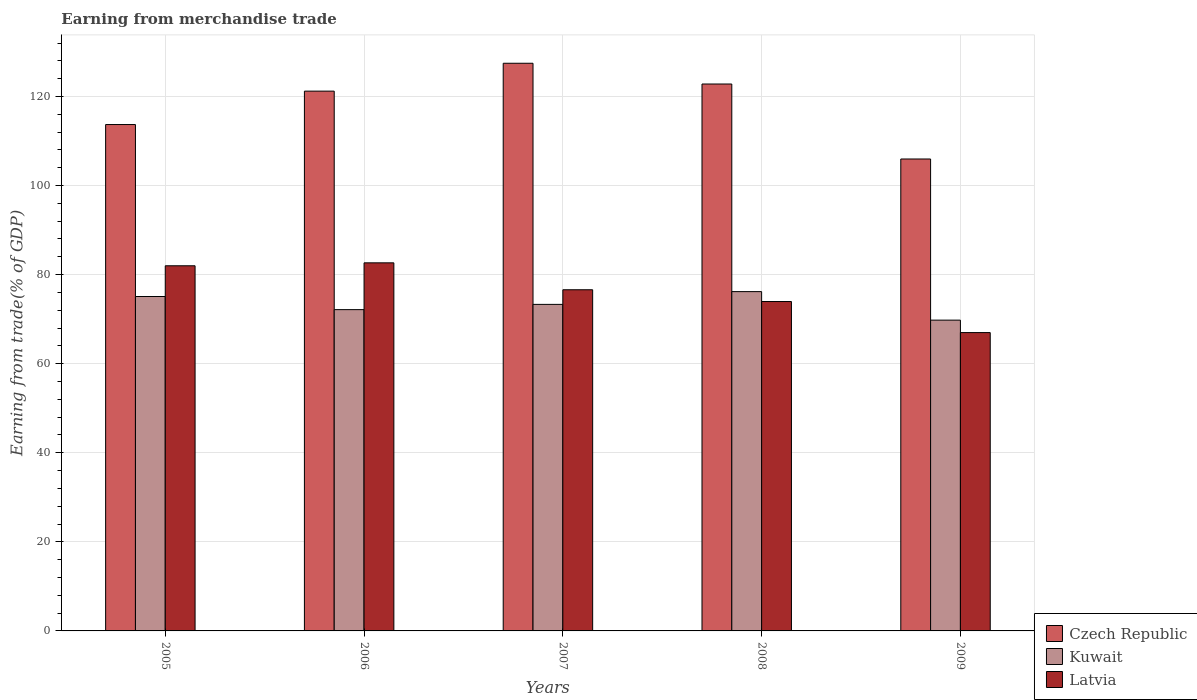How many different coloured bars are there?
Keep it short and to the point. 3. How many bars are there on the 3rd tick from the right?
Keep it short and to the point. 3. What is the earnings from trade in Kuwait in 2008?
Provide a short and direct response. 76.19. Across all years, what is the maximum earnings from trade in Kuwait?
Your answer should be very brief. 76.19. Across all years, what is the minimum earnings from trade in Czech Republic?
Ensure brevity in your answer.  105.97. In which year was the earnings from trade in Kuwait maximum?
Your response must be concise. 2008. What is the total earnings from trade in Latvia in the graph?
Provide a short and direct response. 382.18. What is the difference between the earnings from trade in Kuwait in 2005 and that in 2007?
Your answer should be compact. 1.77. What is the difference between the earnings from trade in Latvia in 2005 and the earnings from trade in Czech Republic in 2006?
Provide a short and direct response. -39.21. What is the average earnings from trade in Kuwait per year?
Offer a very short reply. 73.3. In the year 2006, what is the difference between the earnings from trade in Czech Republic and earnings from trade in Kuwait?
Make the answer very short. 49.06. What is the ratio of the earnings from trade in Czech Republic in 2006 to that in 2007?
Offer a terse response. 0.95. What is the difference between the highest and the second highest earnings from trade in Latvia?
Offer a terse response. 0.66. What is the difference between the highest and the lowest earnings from trade in Kuwait?
Offer a terse response. 6.4. In how many years, is the earnings from trade in Czech Republic greater than the average earnings from trade in Czech Republic taken over all years?
Provide a short and direct response. 3. Is the sum of the earnings from trade in Czech Republic in 2007 and 2008 greater than the maximum earnings from trade in Latvia across all years?
Make the answer very short. Yes. What does the 2nd bar from the left in 2007 represents?
Provide a succinct answer. Kuwait. What does the 1st bar from the right in 2008 represents?
Your response must be concise. Latvia. Is it the case that in every year, the sum of the earnings from trade in Czech Republic and earnings from trade in Latvia is greater than the earnings from trade in Kuwait?
Keep it short and to the point. Yes. How many years are there in the graph?
Make the answer very short. 5. Are the values on the major ticks of Y-axis written in scientific E-notation?
Offer a terse response. No. Does the graph contain any zero values?
Offer a very short reply. No. How many legend labels are there?
Make the answer very short. 3. How are the legend labels stacked?
Give a very brief answer. Vertical. What is the title of the graph?
Give a very brief answer. Earning from merchandise trade. Does "Vietnam" appear as one of the legend labels in the graph?
Provide a succinct answer. No. What is the label or title of the Y-axis?
Ensure brevity in your answer.  Earning from trade(% of GDP). What is the Earning from trade(% of GDP) in Czech Republic in 2005?
Your answer should be compact. 113.7. What is the Earning from trade(% of GDP) in Kuwait in 2005?
Provide a succinct answer. 75.09. What is the Earning from trade(% of GDP) of Latvia in 2005?
Offer a terse response. 81.99. What is the Earning from trade(% of GDP) in Czech Republic in 2006?
Make the answer very short. 121.2. What is the Earning from trade(% of GDP) of Kuwait in 2006?
Give a very brief answer. 72.14. What is the Earning from trade(% of GDP) of Latvia in 2006?
Offer a terse response. 82.65. What is the Earning from trade(% of GDP) in Czech Republic in 2007?
Keep it short and to the point. 127.46. What is the Earning from trade(% of GDP) in Kuwait in 2007?
Your answer should be compact. 73.32. What is the Earning from trade(% of GDP) of Latvia in 2007?
Offer a very short reply. 76.6. What is the Earning from trade(% of GDP) of Czech Republic in 2008?
Ensure brevity in your answer.  122.8. What is the Earning from trade(% of GDP) of Kuwait in 2008?
Provide a short and direct response. 76.19. What is the Earning from trade(% of GDP) in Latvia in 2008?
Ensure brevity in your answer.  73.96. What is the Earning from trade(% of GDP) of Czech Republic in 2009?
Offer a very short reply. 105.97. What is the Earning from trade(% of GDP) in Kuwait in 2009?
Provide a short and direct response. 69.78. What is the Earning from trade(% of GDP) of Latvia in 2009?
Provide a succinct answer. 66.99. Across all years, what is the maximum Earning from trade(% of GDP) in Czech Republic?
Make the answer very short. 127.46. Across all years, what is the maximum Earning from trade(% of GDP) of Kuwait?
Provide a short and direct response. 76.19. Across all years, what is the maximum Earning from trade(% of GDP) in Latvia?
Provide a succinct answer. 82.65. Across all years, what is the minimum Earning from trade(% of GDP) in Czech Republic?
Give a very brief answer. 105.97. Across all years, what is the minimum Earning from trade(% of GDP) in Kuwait?
Make the answer very short. 69.78. Across all years, what is the minimum Earning from trade(% of GDP) in Latvia?
Keep it short and to the point. 66.99. What is the total Earning from trade(% of GDP) in Czech Republic in the graph?
Keep it short and to the point. 591.13. What is the total Earning from trade(% of GDP) of Kuwait in the graph?
Your answer should be very brief. 366.52. What is the total Earning from trade(% of GDP) in Latvia in the graph?
Offer a terse response. 382.18. What is the difference between the Earning from trade(% of GDP) of Czech Republic in 2005 and that in 2006?
Your answer should be very brief. -7.5. What is the difference between the Earning from trade(% of GDP) of Kuwait in 2005 and that in 2006?
Your answer should be compact. 2.95. What is the difference between the Earning from trade(% of GDP) of Latvia in 2005 and that in 2006?
Ensure brevity in your answer.  -0.66. What is the difference between the Earning from trade(% of GDP) in Czech Republic in 2005 and that in 2007?
Provide a succinct answer. -13.76. What is the difference between the Earning from trade(% of GDP) in Kuwait in 2005 and that in 2007?
Keep it short and to the point. 1.77. What is the difference between the Earning from trade(% of GDP) of Latvia in 2005 and that in 2007?
Keep it short and to the point. 5.38. What is the difference between the Earning from trade(% of GDP) in Czech Republic in 2005 and that in 2008?
Make the answer very short. -9.1. What is the difference between the Earning from trade(% of GDP) of Kuwait in 2005 and that in 2008?
Keep it short and to the point. -1.1. What is the difference between the Earning from trade(% of GDP) of Latvia in 2005 and that in 2008?
Provide a succinct answer. 8.03. What is the difference between the Earning from trade(% of GDP) in Czech Republic in 2005 and that in 2009?
Make the answer very short. 7.74. What is the difference between the Earning from trade(% of GDP) of Kuwait in 2005 and that in 2009?
Your answer should be compact. 5.31. What is the difference between the Earning from trade(% of GDP) in Latvia in 2005 and that in 2009?
Provide a succinct answer. 15. What is the difference between the Earning from trade(% of GDP) of Czech Republic in 2006 and that in 2007?
Keep it short and to the point. -6.26. What is the difference between the Earning from trade(% of GDP) in Kuwait in 2006 and that in 2007?
Your answer should be very brief. -1.18. What is the difference between the Earning from trade(% of GDP) of Latvia in 2006 and that in 2007?
Provide a short and direct response. 6.04. What is the difference between the Earning from trade(% of GDP) in Czech Republic in 2006 and that in 2008?
Your answer should be compact. -1.6. What is the difference between the Earning from trade(% of GDP) of Kuwait in 2006 and that in 2008?
Give a very brief answer. -4.05. What is the difference between the Earning from trade(% of GDP) in Latvia in 2006 and that in 2008?
Provide a short and direct response. 8.69. What is the difference between the Earning from trade(% of GDP) in Czech Republic in 2006 and that in 2009?
Offer a terse response. 15.23. What is the difference between the Earning from trade(% of GDP) in Kuwait in 2006 and that in 2009?
Provide a short and direct response. 2.36. What is the difference between the Earning from trade(% of GDP) in Latvia in 2006 and that in 2009?
Ensure brevity in your answer.  15.66. What is the difference between the Earning from trade(% of GDP) in Czech Republic in 2007 and that in 2008?
Your answer should be very brief. 4.66. What is the difference between the Earning from trade(% of GDP) in Kuwait in 2007 and that in 2008?
Make the answer very short. -2.87. What is the difference between the Earning from trade(% of GDP) of Latvia in 2007 and that in 2008?
Ensure brevity in your answer.  2.64. What is the difference between the Earning from trade(% of GDP) of Czech Republic in 2007 and that in 2009?
Provide a succinct answer. 21.49. What is the difference between the Earning from trade(% of GDP) in Kuwait in 2007 and that in 2009?
Provide a short and direct response. 3.54. What is the difference between the Earning from trade(% of GDP) of Latvia in 2007 and that in 2009?
Offer a very short reply. 9.62. What is the difference between the Earning from trade(% of GDP) of Czech Republic in 2008 and that in 2009?
Make the answer very short. 16.84. What is the difference between the Earning from trade(% of GDP) in Kuwait in 2008 and that in 2009?
Ensure brevity in your answer.  6.4. What is the difference between the Earning from trade(% of GDP) in Latvia in 2008 and that in 2009?
Offer a very short reply. 6.97. What is the difference between the Earning from trade(% of GDP) of Czech Republic in 2005 and the Earning from trade(% of GDP) of Kuwait in 2006?
Offer a terse response. 41.56. What is the difference between the Earning from trade(% of GDP) in Czech Republic in 2005 and the Earning from trade(% of GDP) in Latvia in 2006?
Offer a terse response. 31.05. What is the difference between the Earning from trade(% of GDP) of Kuwait in 2005 and the Earning from trade(% of GDP) of Latvia in 2006?
Make the answer very short. -7.56. What is the difference between the Earning from trade(% of GDP) of Czech Republic in 2005 and the Earning from trade(% of GDP) of Kuwait in 2007?
Provide a succinct answer. 40.38. What is the difference between the Earning from trade(% of GDP) of Czech Republic in 2005 and the Earning from trade(% of GDP) of Latvia in 2007?
Provide a succinct answer. 37.1. What is the difference between the Earning from trade(% of GDP) of Kuwait in 2005 and the Earning from trade(% of GDP) of Latvia in 2007?
Keep it short and to the point. -1.52. What is the difference between the Earning from trade(% of GDP) of Czech Republic in 2005 and the Earning from trade(% of GDP) of Kuwait in 2008?
Give a very brief answer. 37.51. What is the difference between the Earning from trade(% of GDP) in Czech Republic in 2005 and the Earning from trade(% of GDP) in Latvia in 2008?
Give a very brief answer. 39.74. What is the difference between the Earning from trade(% of GDP) in Kuwait in 2005 and the Earning from trade(% of GDP) in Latvia in 2008?
Your response must be concise. 1.13. What is the difference between the Earning from trade(% of GDP) of Czech Republic in 2005 and the Earning from trade(% of GDP) of Kuwait in 2009?
Make the answer very short. 43.92. What is the difference between the Earning from trade(% of GDP) of Czech Republic in 2005 and the Earning from trade(% of GDP) of Latvia in 2009?
Your answer should be very brief. 46.72. What is the difference between the Earning from trade(% of GDP) in Kuwait in 2005 and the Earning from trade(% of GDP) in Latvia in 2009?
Your answer should be compact. 8.1. What is the difference between the Earning from trade(% of GDP) in Czech Republic in 2006 and the Earning from trade(% of GDP) in Kuwait in 2007?
Make the answer very short. 47.88. What is the difference between the Earning from trade(% of GDP) in Czech Republic in 2006 and the Earning from trade(% of GDP) in Latvia in 2007?
Make the answer very short. 44.6. What is the difference between the Earning from trade(% of GDP) of Kuwait in 2006 and the Earning from trade(% of GDP) of Latvia in 2007?
Your response must be concise. -4.46. What is the difference between the Earning from trade(% of GDP) in Czech Republic in 2006 and the Earning from trade(% of GDP) in Kuwait in 2008?
Offer a terse response. 45.01. What is the difference between the Earning from trade(% of GDP) in Czech Republic in 2006 and the Earning from trade(% of GDP) in Latvia in 2008?
Offer a very short reply. 47.24. What is the difference between the Earning from trade(% of GDP) in Kuwait in 2006 and the Earning from trade(% of GDP) in Latvia in 2008?
Ensure brevity in your answer.  -1.82. What is the difference between the Earning from trade(% of GDP) of Czech Republic in 2006 and the Earning from trade(% of GDP) of Kuwait in 2009?
Offer a terse response. 51.42. What is the difference between the Earning from trade(% of GDP) of Czech Republic in 2006 and the Earning from trade(% of GDP) of Latvia in 2009?
Your answer should be compact. 54.22. What is the difference between the Earning from trade(% of GDP) of Kuwait in 2006 and the Earning from trade(% of GDP) of Latvia in 2009?
Keep it short and to the point. 5.15. What is the difference between the Earning from trade(% of GDP) of Czech Republic in 2007 and the Earning from trade(% of GDP) of Kuwait in 2008?
Ensure brevity in your answer.  51.27. What is the difference between the Earning from trade(% of GDP) in Czech Republic in 2007 and the Earning from trade(% of GDP) in Latvia in 2008?
Provide a succinct answer. 53.5. What is the difference between the Earning from trade(% of GDP) in Kuwait in 2007 and the Earning from trade(% of GDP) in Latvia in 2008?
Make the answer very short. -0.64. What is the difference between the Earning from trade(% of GDP) of Czech Republic in 2007 and the Earning from trade(% of GDP) of Kuwait in 2009?
Provide a short and direct response. 57.68. What is the difference between the Earning from trade(% of GDP) in Czech Republic in 2007 and the Earning from trade(% of GDP) in Latvia in 2009?
Provide a succinct answer. 60.47. What is the difference between the Earning from trade(% of GDP) in Kuwait in 2007 and the Earning from trade(% of GDP) in Latvia in 2009?
Provide a succinct answer. 6.33. What is the difference between the Earning from trade(% of GDP) of Czech Republic in 2008 and the Earning from trade(% of GDP) of Kuwait in 2009?
Provide a succinct answer. 53.02. What is the difference between the Earning from trade(% of GDP) in Czech Republic in 2008 and the Earning from trade(% of GDP) in Latvia in 2009?
Your response must be concise. 55.82. What is the difference between the Earning from trade(% of GDP) of Kuwait in 2008 and the Earning from trade(% of GDP) of Latvia in 2009?
Make the answer very short. 9.2. What is the average Earning from trade(% of GDP) in Czech Republic per year?
Offer a very short reply. 118.23. What is the average Earning from trade(% of GDP) in Kuwait per year?
Provide a succinct answer. 73.3. What is the average Earning from trade(% of GDP) in Latvia per year?
Provide a succinct answer. 76.44. In the year 2005, what is the difference between the Earning from trade(% of GDP) of Czech Republic and Earning from trade(% of GDP) of Kuwait?
Provide a succinct answer. 38.61. In the year 2005, what is the difference between the Earning from trade(% of GDP) in Czech Republic and Earning from trade(% of GDP) in Latvia?
Offer a terse response. 31.71. In the year 2005, what is the difference between the Earning from trade(% of GDP) in Kuwait and Earning from trade(% of GDP) in Latvia?
Give a very brief answer. -6.9. In the year 2006, what is the difference between the Earning from trade(% of GDP) in Czech Republic and Earning from trade(% of GDP) in Kuwait?
Your answer should be very brief. 49.06. In the year 2006, what is the difference between the Earning from trade(% of GDP) of Czech Republic and Earning from trade(% of GDP) of Latvia?
Offer a very short reply. 38.55. In the year 2006, what is the difference between the Earning from trade(% of GDP) in Kuwait and Earning from trade(% of GDP) in Latvia?
Your answer should be compact. -10.51. In the year 2007, what is the difference between the Earning from trade(% of GDP) of Czech Republic and Earning from trade(% of GDP) of Kuwait?
Keep it short and to the point. 54.14. In the year 2007, what is the difference between the Earning from trade(% of GDP) in Czech Republic and Earning from trade(% of GDP) in Latvia?
Your response must be concise. 50.86. In the year 2007, what is the difference between the Earning from trade(% of GDP) in Kuwait and Earning from trade(% of GDP) in Latvia?
Keep it short and to the point. -3.29. In the year 2008, what is the difference between the Earning from trade(% of GDP) of Czech Republic and Earning from trade(% of GDP) of Kuwait?
Keep it short and to the point. 46.62. In the year 2008, what is the difference between the Earning from trade(% of GDP) of Czech Republic and Earning from trade(% of GDP) of Latvia?
Offer a very short reply. 48.84. In the year 2008, what is the difference between the Earning from trade(% of GDP) in Kuwait and Earning from trade(% of GDP) in Latvia?
Your answer should be compact. 2.23. In the year 2009, what is the difference between the Earning from trade(% of GDP) in Czech Republic and Earning from trade(% of GDP) in Kuwait?
Offer a very short reply. 36.18. In the year 2009, what is the difference between the Earning from trade(% of GDP) in Czech Republic and Earning from trade(% of GDP) in Latvia?
Provide a short and direct response. 38.98. In the year 2009, what is the difference between the Earning from trade(% of GDP) of Kuwait and Earning from trade(% of GDP) of Latvia?
Your answer should be compact. 2.8. What is the ratio of the Earning from trade(% of GDP) of Czech Republic in 2005 to that in 2006?
Your answer should be very brief. 0.94. What is the ratio of the Earning from trade(% of GDP) of Kuwait in 2005 to that in 2006?
Provide a succinct answer. 1.04. What is the ratio of the Earning from trade(% of GDP) of Czech Republic in 2005 to that in 2007?
Your answer should be very brief. 0.89. What is the ratio of the Earning from trade(% of GDP) of Kuwait in 2005 to that in 2007?
Ensure brevity in your answer.  1.02. What is the ratio of the Earning from trade(% of GDP) in Latvia in 2005 to that in 2007?
Offer a terse response. 1.07. What is the ratio of the Earning from trade(% of GDP) in Czech Republic in 2005 to that in 2008?
Offer a very short reply. 0.93. What is the ratio of the Earning from trade(% of GDP) of Kuwait in 2005 to that in 2008?
Give a very brief answer. 0.99. What is the ratio of the Earning from trade(% of GDP) in Latvia in 2005 to that in 2008?
Provide a succinct answer. 1.11. What is the ratio of the Earning from trade(% of GDP) of Czech Republic in 2005 to that in 2009?
Ensure brevity in your answer.  1.07. What is the ratio of the Earning from trade(% of GDP) in Kuwait in 2005 to that in 2009?
Provide a short and direct response. 1.08. What is the ratio of the Earning from trade(% of GDP) of Latvia in 2005 to that in 2009?
Provide a short and direct response. 1.22. What is the ratio of the Earning from trade(% of GDP) in Czech Republic in 2006 to that in 2007?
Offer a very short reply. 0.95. What is the ratio of the Earning from trade(% of GDP) in Kuwait in 2006 to that in 2007?
Keep it short and to the point. 0.98. What is the ratio of the Earning from trade(% of GDP) of Latvia in 2006 to that in 2007?
Give a very brief answer. 1.08. What is the ratio of the Earning from trade(% of GDP) in Czech Republic in 2006 to that in 2008?
Make the answer very short. 0.99. What is the ratio of the Earning from trade(% of GDP) of Kuwait in 2006 to that in 2008?
Ensure brevity in your answer.  0.95. What is the ratio of the Earning from trade(% of GDP) of Latvia in 2006 to that in 2008?
Ensure brevity in your answer.  1.12. What is the ratio of the Earning from trade(% of GDP) in Czech Republic in 2006 to that in 2009?
Your response must be concise. 1.14. What is the ratio of the Earning from trade(% of GDP) of Kuwait in 2006 to that in 2009?
Give a very brief answer. 1.03. What is the ratio of the Earning from trade(% of GDP) in Latvia in 2006 to that in 2009?
Provide a succinct answer. 1.23. What is the ratio of the Earning from trade(% of GDP) of Czech Republic in 2007 to that in 2008?
Your response must be concise. 1.04. What is the ratio of the Earning from trade(% of GDP) in Kuwait in 2007 to that in 2008?
Your answer should be very brief. 0.96. What is the ratio of the Earning from trade(% of GDP) of Latvia in 2007 to that in 2008?
Your answer should be very brief. 1.04. What is the ratio of the Earning from trade(% of GDP) in Czech Republic in 2007 to that in 2009?
Your answer should be very brief. 1.2. What is the ratio of the Earning from trade(% of GDP) of Kuwait in 2007 to that in 2009?
Your answer should be compact. 1.05. What is the ratio of the Earning from trade(% of GDP) of Latvia in 2007 to that in 2009?
Your response must be concise. 1.14. What is the ratio of the Earning from trade(% of GDP) of Czech Republic in 2008 to that in 2009?
Your answer should be very brief. 1.16. What is the ratio of the Earning from trade(% of GDP) of Kuwait in 2008 to that in 2009?
Provide a succinct answer. 1.09. What is the ratio of the Earning from trade(% of GDP) in Latvia in 2008 to that in 2009?
Your response must be concise. 1.1. What is the difference between the highest and the second highest Earning from trade(% of GDP) in Czech Republic?
Provide a succinct answer. 4.66. What is the difference between the highest and the second highest Earning from trade(% of GDP) of Kuwait?
Provide a short and direct response. 1.1. What is the difference between the highest and the second highest Earning from trade(% of GDP) in Latvia?
Provide a short and direct response. 0.66. What is the difference between the highest and the lowest Earning from trade(% of GDP) in Czech Republic?
Offer a terse response. 21.49. What is the difference between the highest and the lowest Earning from trade(% of GDP) of Kuwait?
Provide a short and direct response. 6.4. What is the difference between the highest and the lowest Earning from trade(% of GDP) of Latvia?
Offer a very short reply. 15.66. 